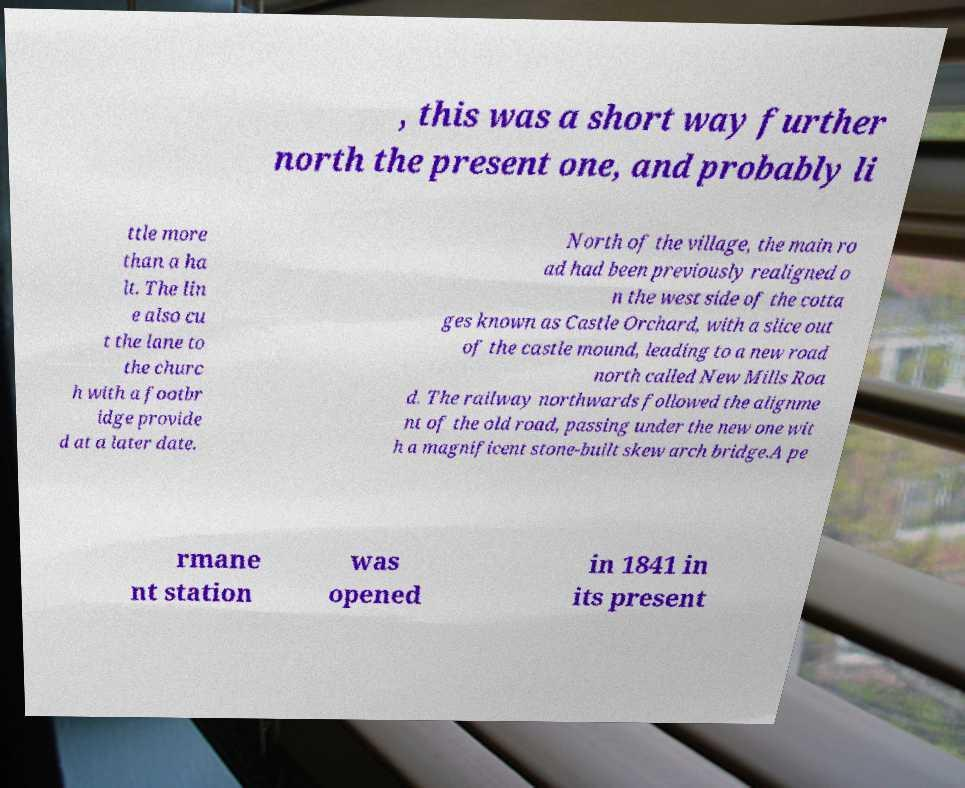I need the written content from this picture converted into text. Can you do that? , this was a short way further north the present one, and probably li ttle more than a ha lt. The lin e also cu t the lane to the churc h with a footbr idge provide d at a later date. North of the village, the main ro ad had been previously realigned o n the west side of the cotta ges known as Castle Orchard, with a slice out of the castle mound, leading to a new road north called New Mills Roa d. The railway northwards followed the alignme nt of the old road, passing under the new one wit h a magnificent stone-built skew arch bridge.A pe rmane nt station was opened in 1841 in its present 